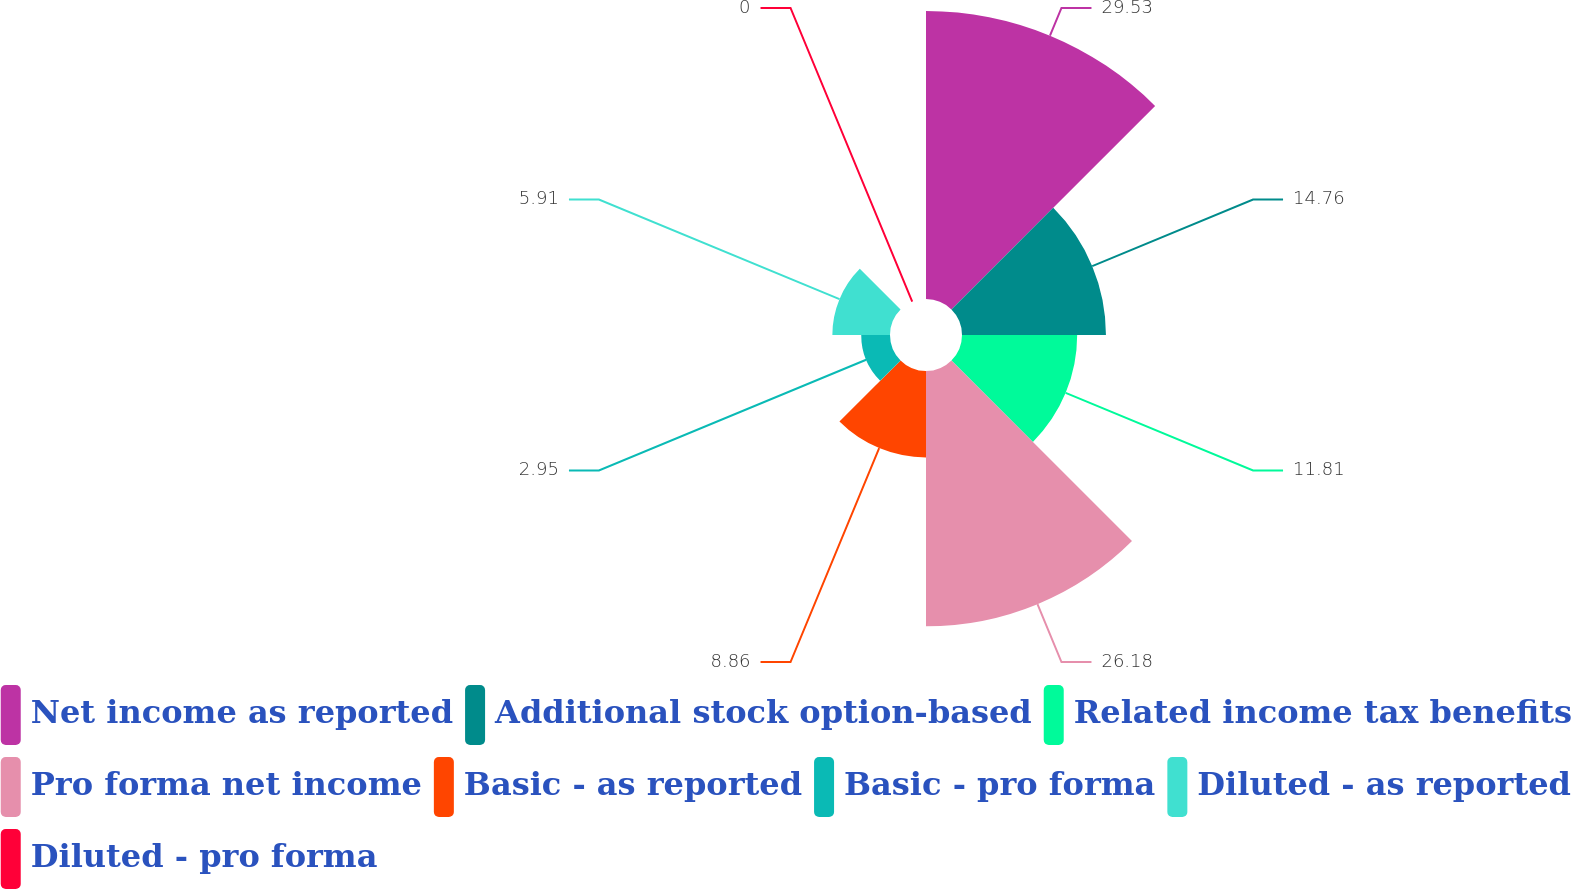Convert chart to OTSL. <chart><loc_0><loc_0><loc_500><loc_500><pie_chart><fcel>Net income as reported<fcel>Additional stock option-based<fcel>Related income tax benefits<fcel>Pro forma net income<fcel>Basic - as reported<fcel>Basic - pro forma<fcel>Diluted - as reported<fcel>Diluted - pro forma<nl><fcel>29.53%<fcel>14.76%<fcel>11.81%<fcel>26.18%<fcel>8.86%<fcel>2.95%<fcel>5.91%<fcel>0.0%<nl></chart> 